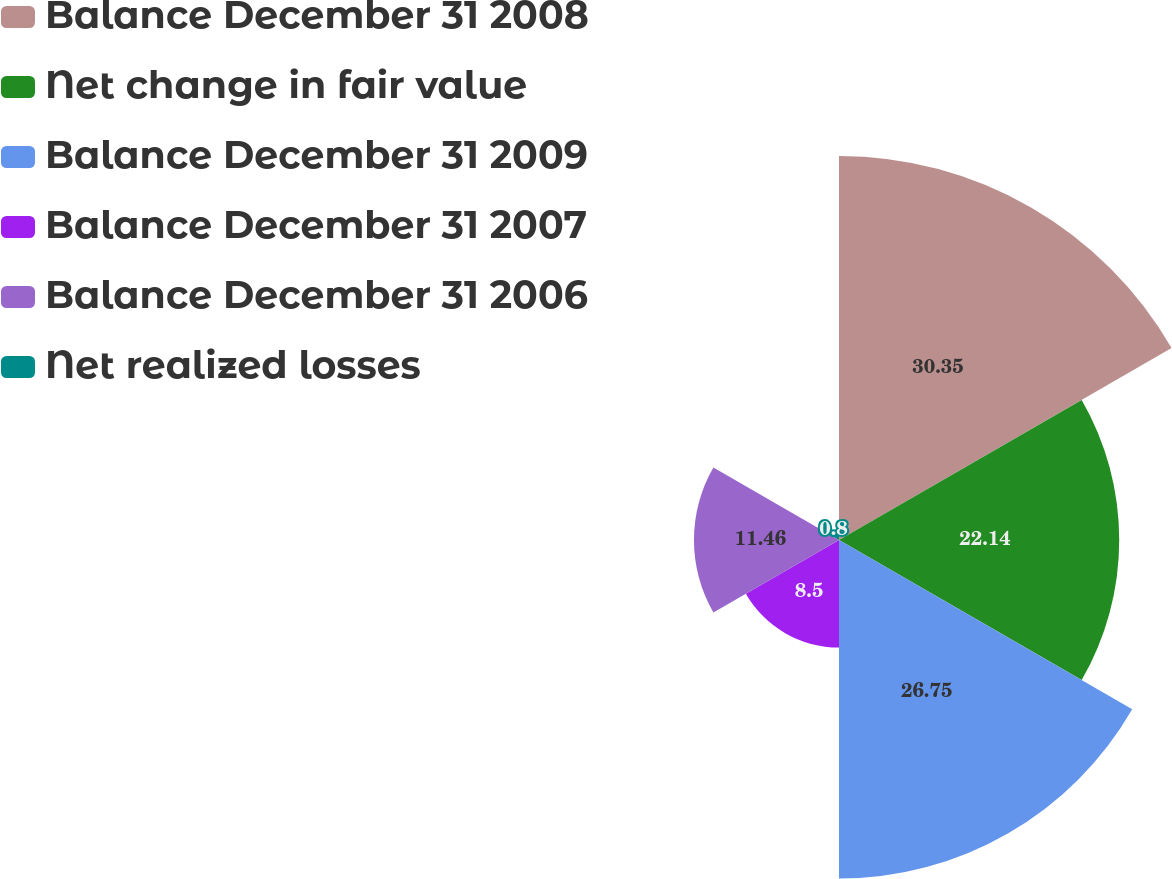Convert chart to OTSL. <chart><loc_0><loc_0><loc_500><loc_500><pie_chart><fcel>Balance December 31 2008<fcel>Net change in fair value<fcel>Balance December 31 2009<fcel>Balance December 31 2007<fcel>Balance December 31 2006<fcel>Net realized losses<nl><fcel>30.34%<fcel>22.14%<fcel>26.75%<fcel>8.5%<fcel>11.46%<fcel>0.8%<nl></chart> 